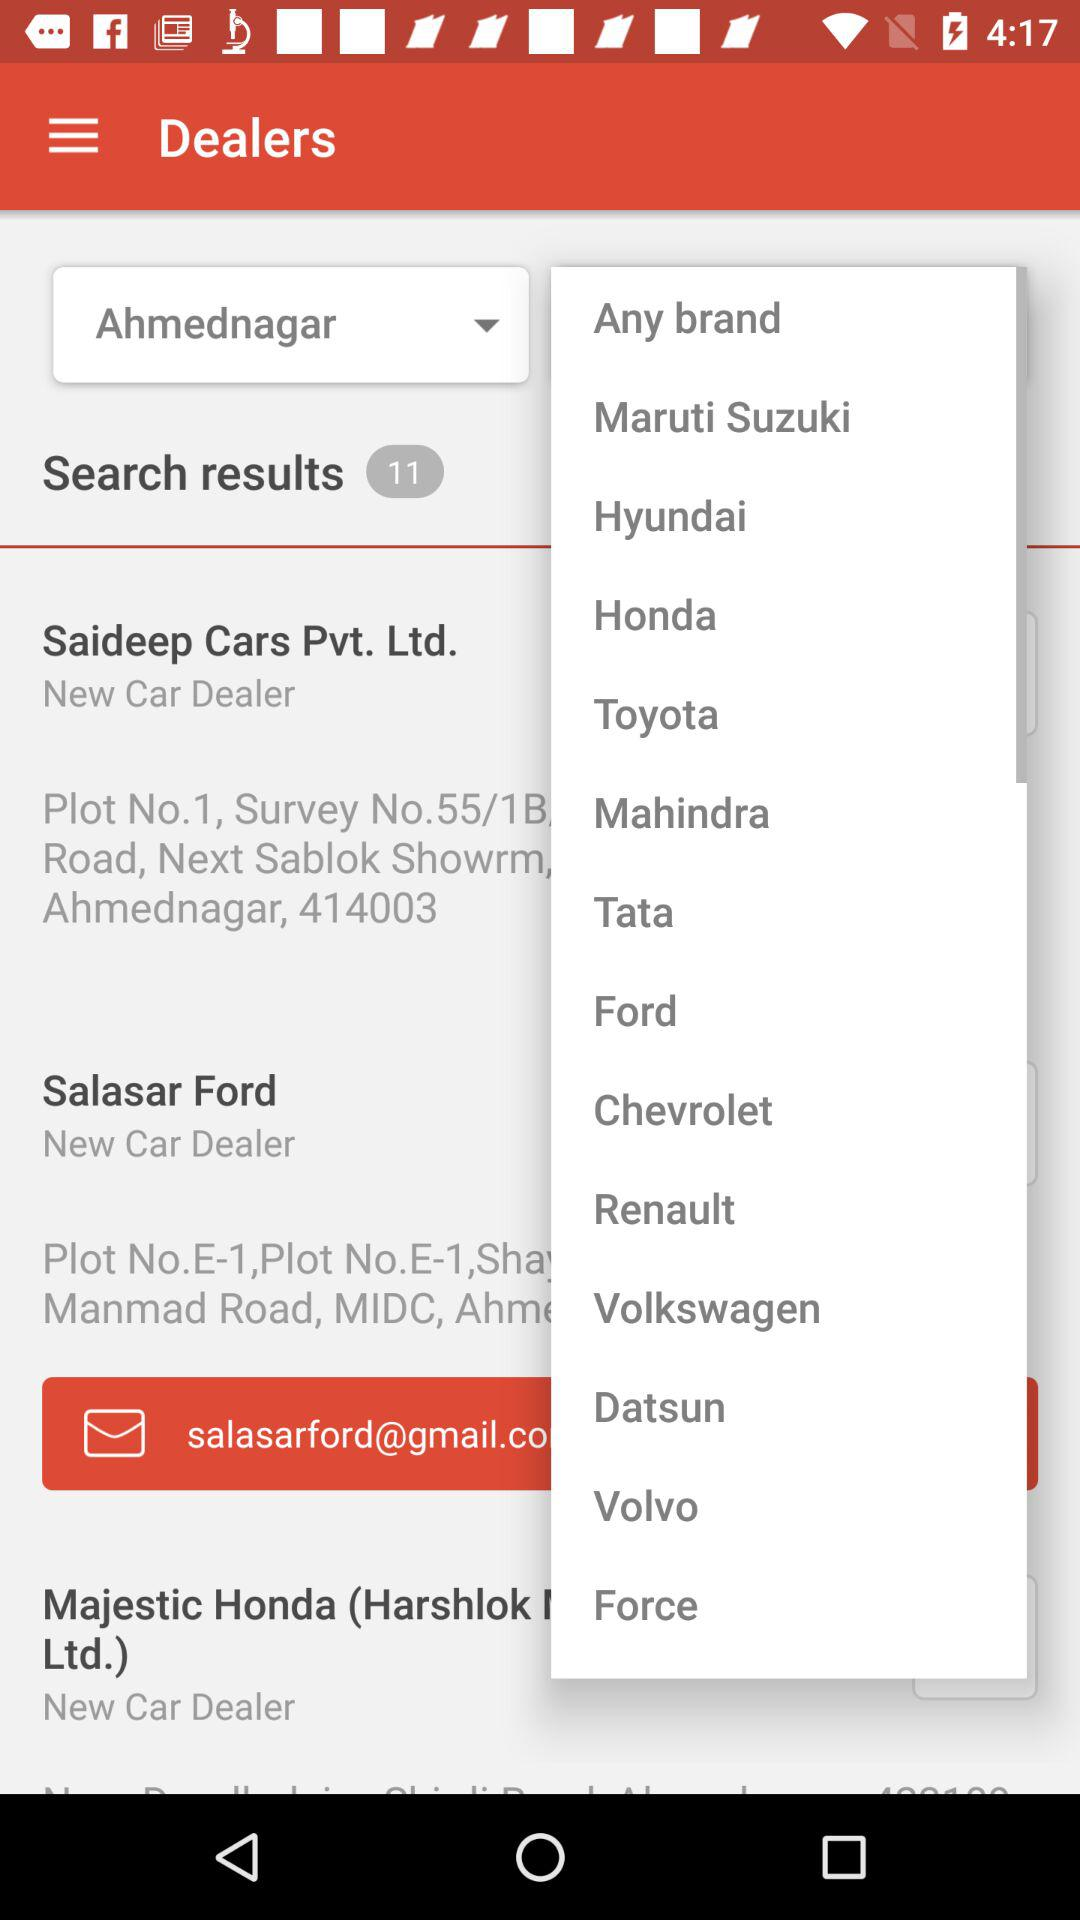What is the location? The location is Ahmednagar. 